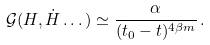<formula> <loc_0><loc_0><loc_500><loc_500>\mathcal { G } ( H , \dot { H } \dots ) \simeq \frac { \alpha } { ( t _ { 0 } - t ) ^ { 4 \beta m } } \, .</formula> 